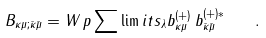Convert formula to latex. <formula><loc_0><loc_0><loc_500><loc_500>B _ { \kappa \mu ; \bar { \kappa } \bar { \mu } } = W \, p \sum \lim i t s _ { \lambda } b ^ { ( + ) } _ { \kappa \mu } \, b ^ { ( + ) * } _ { \bar { \kappa } \bar { \mu } } \quad .</formula> 